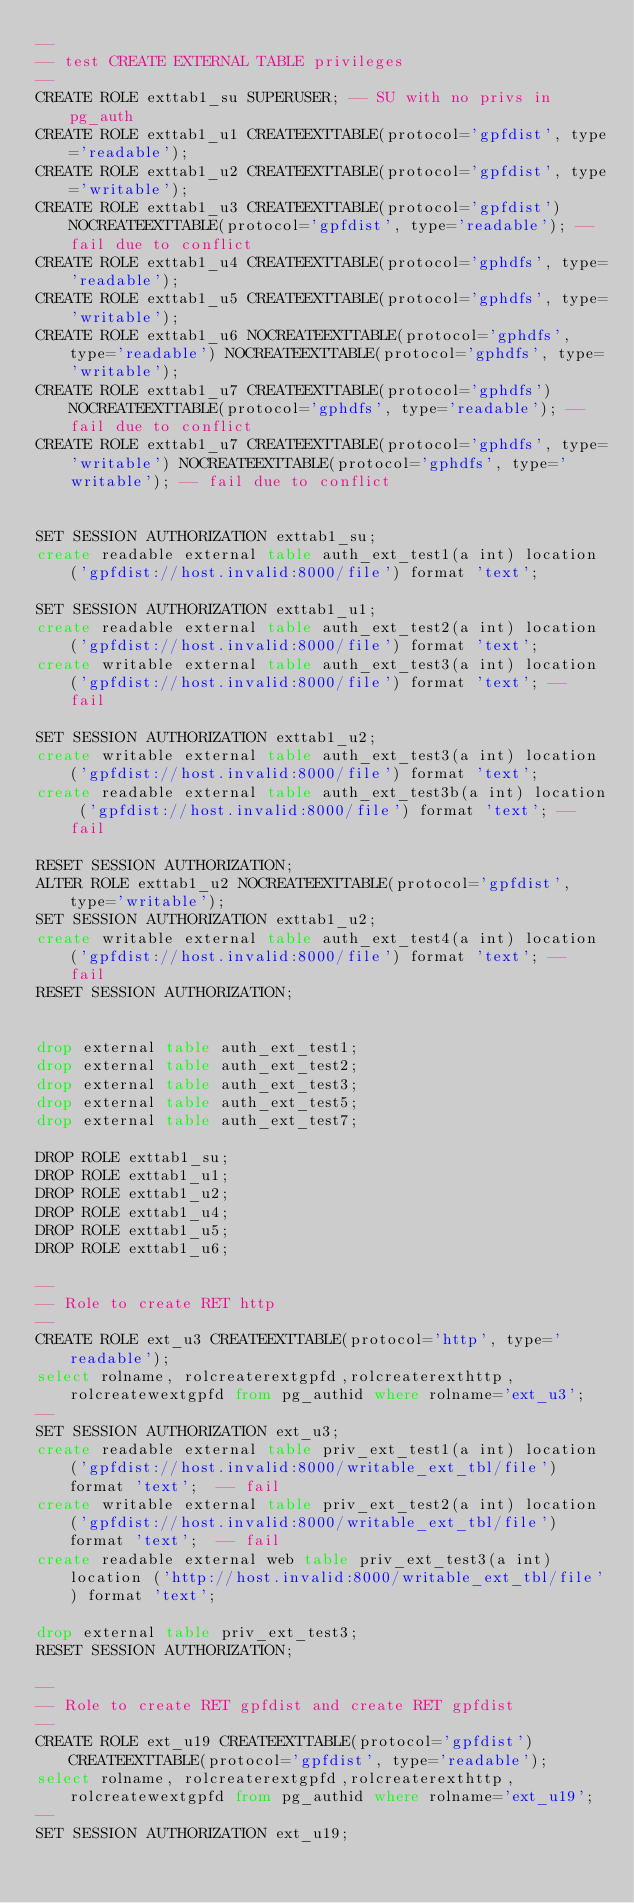Convert code to text. <code><loc_0><loc_0><loc_500><loc_500><_SQL_>--
-- test CREATE EXTERNAL TABLE privileges
--
CREATE ROLE exttab1_su SUPERUSER; -- SU with no privs in pg_auth
CREATE ROLE exttab1_u1 CREATEEXTTABLE(protocol='gpfdist', type='readable'); 
CREATE ROLE exttab1_u2 CREATEEXTTABLE(protocol='gpfdist', type='writable'); 
CREATE ROLE exttab1_u3 CREATEEXTTABLE(protocol='gpfdist') NOCREATEEXTTABLE(protocol='gpfdist', type='readable'); -- fail due to conflict 
CREATE ROLE exttab1_u4 CREATEEXTTABLE(protocol='gphdfs', type='readable'); 
CREATE ROLE exttab1_u5 CREATEEXTTABLE(protocol='gphdfs', type='writable'); 
CREATE ROLE exttab1_u6 NOCREATEEXTTABLE(protocol='gphdfs', type='readable') NOCREATEEXTTABLE(protocol='gphdfs', type='writable');
CREATE ROLE exttab1_u7 CREATEEXTTABLE(protocol='gphdfs') NOCREATEEXTTABLE(protocol='gphdfs', type='readable'); -- fail due to conflict 
CREATE ROLE exttab1_u7 CREATEEXTTABLE(protocol='gphdfs', type='writable') NOCREATEEXTTABLE(protocol='gphdfs', type='writable'); -- fail due to conflict 


SET SESSION AUTHORIZATION exttab1_su;
create readable external table auth_ext_test1(a int) location ('gpfdist://host.invalid:8000/file') format 'text';

SET SESSION AUTHORIZATION exttab1_u1;
create readable external table auth_ext_test2(a int) location ('gpfdist://host.invalid:8000/file') format 'text';
create writable external table auth_ext_test3(a int) location ('gpfdist://host.invalid:8000/file') format 'text'; -- fail

SET SESSION AUTHORIZATION exttab1_u2;
create writable external table auth_ext_test3(a int) location ('gpfdist://host.invalid:8000/file') format 'text';
create readable external table auth_ext_test3b(a int) location ('gpfdist://host.invalid:8000/file') format 'text'; -- fail

RESET SESSION AUTHORIZATION;
ALTER ROLE exttab1_u2 NOCREATEEXTTABLE(protocol='gpfdist', type='writable');
SET SESSION AUTHORIZATION exttab1_u2;
create writable external table auth_ext_test4(a int) location ('gpfdist://host.invalid:8000/file') format 'text'; -- fail
RESET SESSION AUTHORIZATION;


drop external table auth_ext_test1;
drop external table auth_ext_test2;
drop external table auth_ext_test3;
drop external table auth_ext_test5;
drop external table auth_ext_test7;

DROP ROLE exttab1_su;
DROP ROLE exttab1_u1;
DROP ROLE exttab1_u2;
DROP ROLE exttab1_u4;
DROP ROLE exttab1_u5;
DROP ROLE exttab1_u6;

--
-- Role to create RET http
--
CREATE ROLE ext_u3 CREATEEXTTABLE(protocol='http', type='readable');
select rolname, rolcreaterextgpfd,rolcreaterexthttp,rolcreatewextgpfd from pg_authid where rolname='ext_u3';
--
SET SESSION AUTHORIZATION ext_u3;
create readable external table priv_ext_test1(a int) location ('gpfdist://host.invalid:8000/writable_ext_tbl/file') format 'text';  -- fail
create writable external table priv_ext_test2(a int) location ('gpfdist://host.invalid:8000/writable_ext_tbl/file') format 'text';  -- fail
create readable external web table priv_ext_test3(a int) location ('http://host.invalid:8000/writable_ext_tbl/file') format 'text';

drop external table priv_ext_test3;
RESET SESSION AUTHORIZATION;

--
-- Role to create RET gpfdist and create RET gpfdist
--
CREATE ROLE ext_u19 CREATEEXTTABLE(protocol='gpfdist') CREATEEXTTABLE(protocol='gpfdist', type='readable'); 
select rolname, rolcreaterextgpfd,rolcreaterexthttp,rolcreatewextgpfd from pg_authid where rolname='ext_u19';
--
SET SESSION AUTHORIZATION ext_u19;</code> 